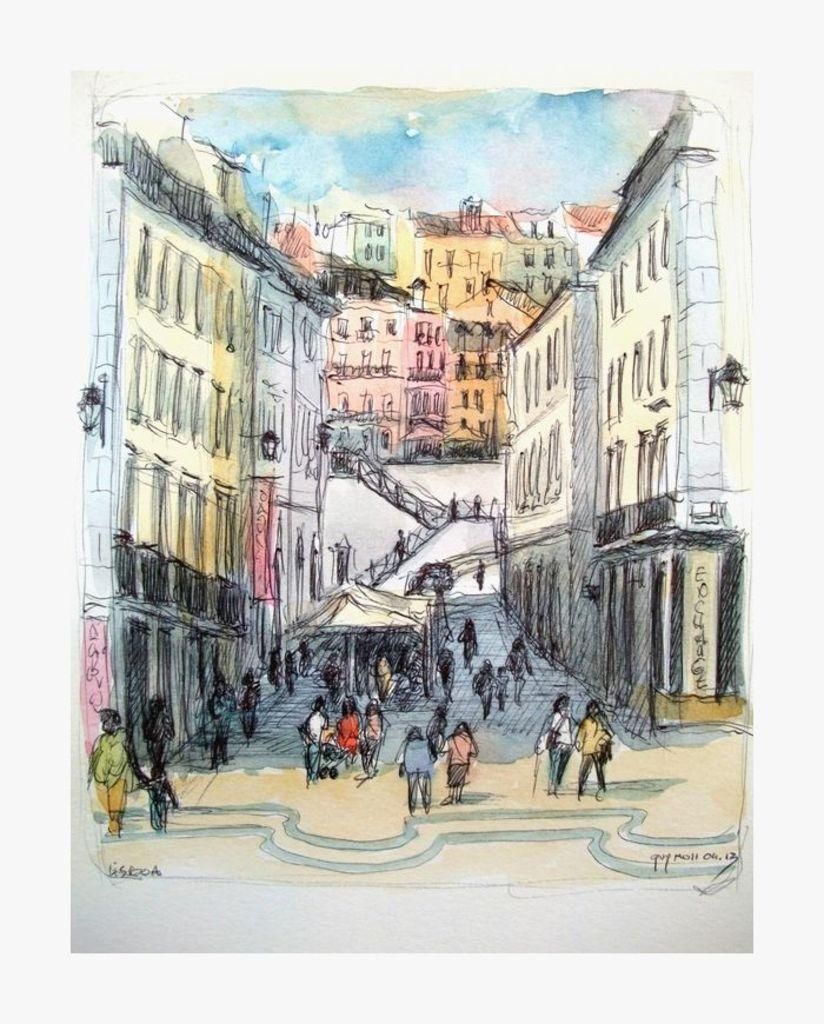What subjects are present in the image? There are persons and buildings depicted in the image. Can you describe the setting of the image? The image features both people and buildings, which suggests an urban or populated environment. What type of cough medicine is visible on the chair in the image? There is no cough medicine or chair present in the image. What time of day is depicted in the image? The time of day is not specified in the image; it could be any time based on the available information. 